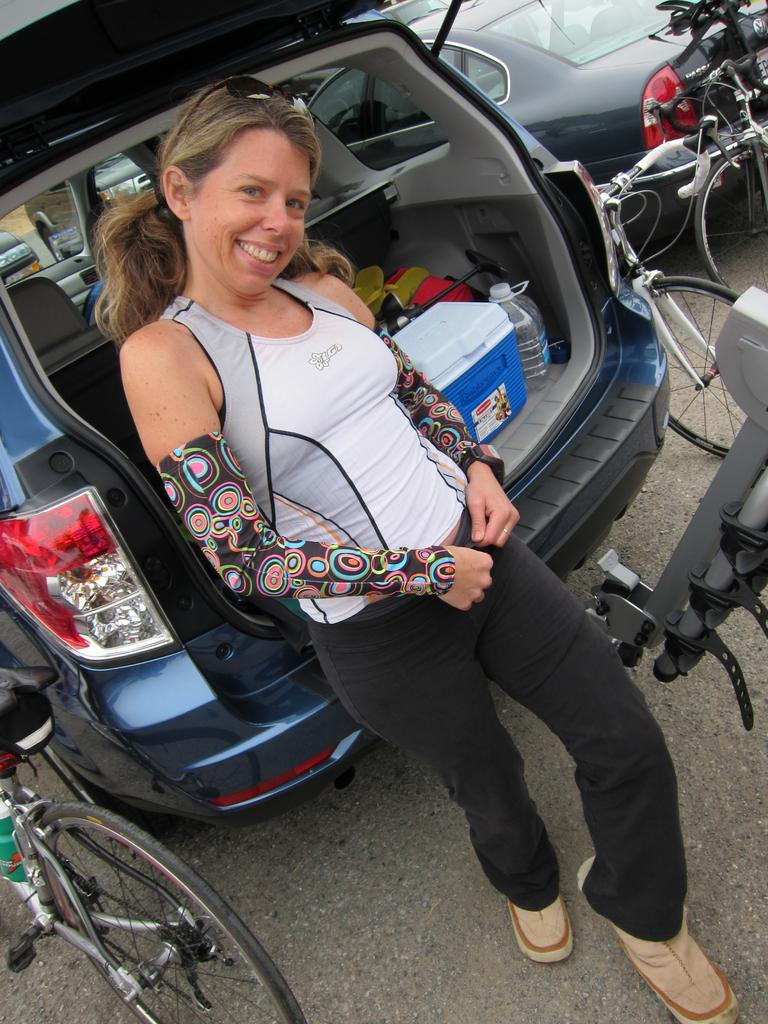Who is the main subject in the image? There is a woman standing in the middle of the image. What is the woman doing in the image? The woman is smiling in the image. What can be seen behind the woman? There are vehicles and bicycles behind the woman. What type of camera is the woman holding in the image? There is no camera visible in the image; the woman is not holding anything. 